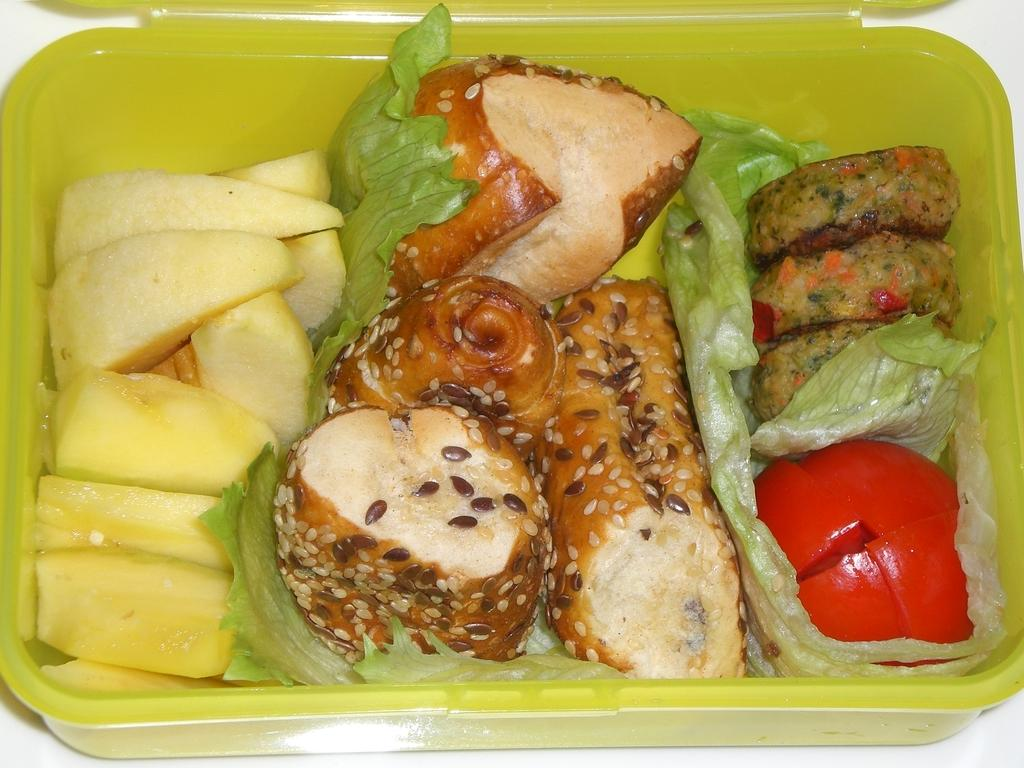What type of objects can be seen in the image? There are food items in the image. How are the food items arranged or contained in the image? The food items are in a box. What type of nut is being used to fix the hose in the image? There is no nut or hose present in the image; it only features food items in a box. 